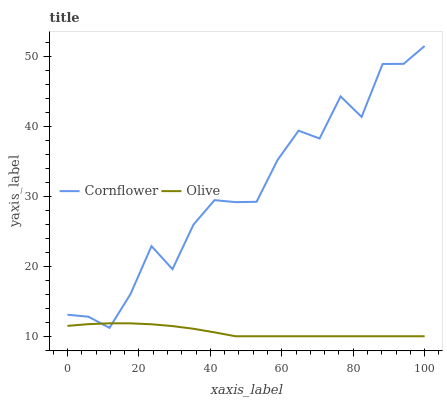Does Olive have the minimum area under the curve?
Answer yes or no. Yes. Does Cornflower have the maximum area under the curve?
Answer yes or no. Yes. Does Cornflower have the minimum area under the curve?
Answer yes or no. No. Is Olive the smoothest?
Answer yes or no. Yes. Is Cornflower the roughest?
Answer yes or no. Yes. Is Cornflower the smoothest?
Answer yes or no. No. Does Olive have the lowest value?
Answer yes or no. Yes. Does Cornflower have the lowest value?
Answer yes or no. No. Does Cornflower have the highest value?
Answer yes or no. Yes. Does Cornflower intersect Olive?
Answer yes or no. Yes. Is Cornflower less than Olive?
Answer yes or no. No. Is Cornflower greater than Olive?
Answer yes or no. No. 